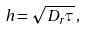<formula> <loc_0><loc_0><loc_500><loc_500>h = \sqrt { D _ { r } \tau } \, ,</formula> 